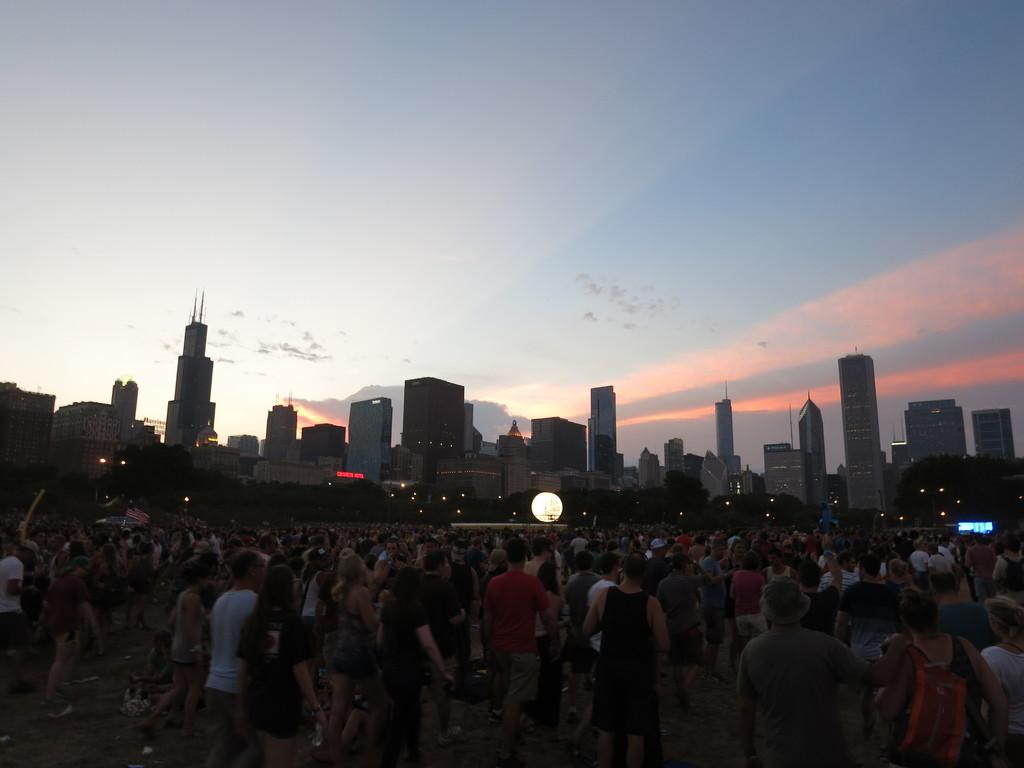What is the main subject of the image? The main subject of the image is a crowd. What can be seen in the background of the image? In the background of the image, there are lights, trees, a screen, buildings, and the sky. What is the condition of the sky in the image? The sky is visible in the background of the image, and clouds are present. What type of music is being played for the crowd's approval in the image? There is no indication of music or approval in the image; it simply shows a crowd with a background containing lights, trees, a screen, buildings, and the sky. 